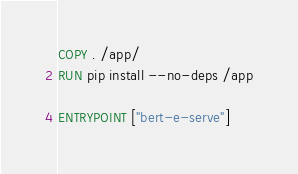Convert code to text. <code><loc_0><loc_0><loc_500><loc_500><_Dockerfile_>COPY . /app/
RUN pip install --no-deps /app

ENTRYPOINT ["bert-e-serve"]
</code> 